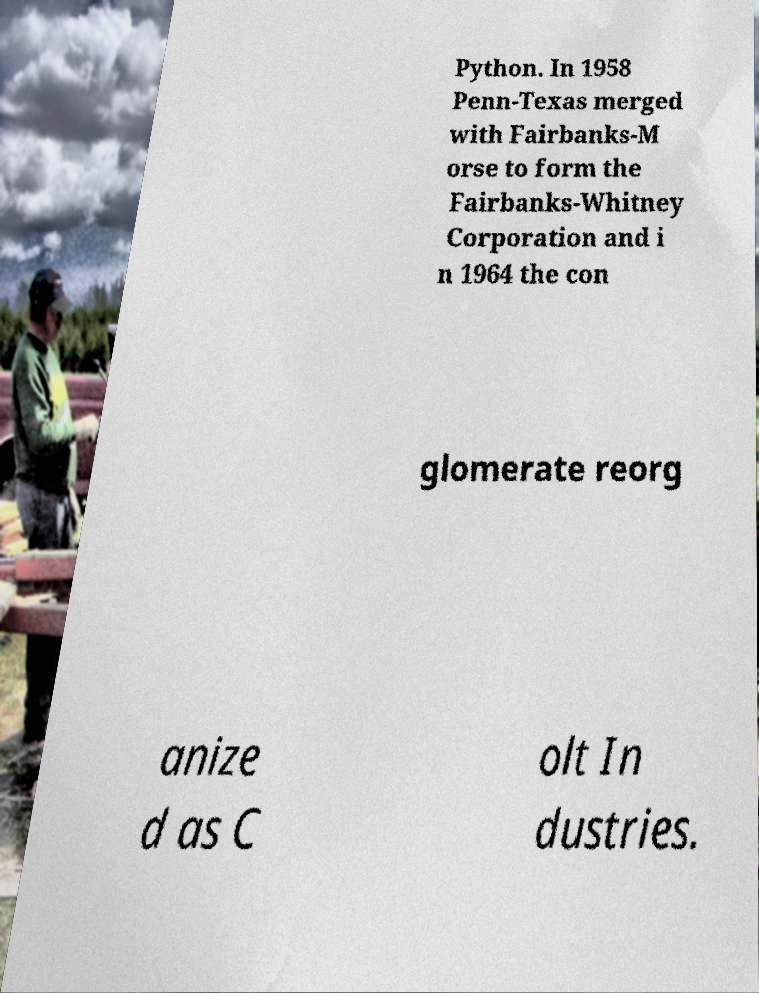Please identify and transcribe the text found in this image. Python. In 1958 Penn-Texas merged with Fairbanks-M orse to form the Fairbanks-Whitney Corporation and i n 1964 the con glomerate reorg anize d as C olt In dustries. 